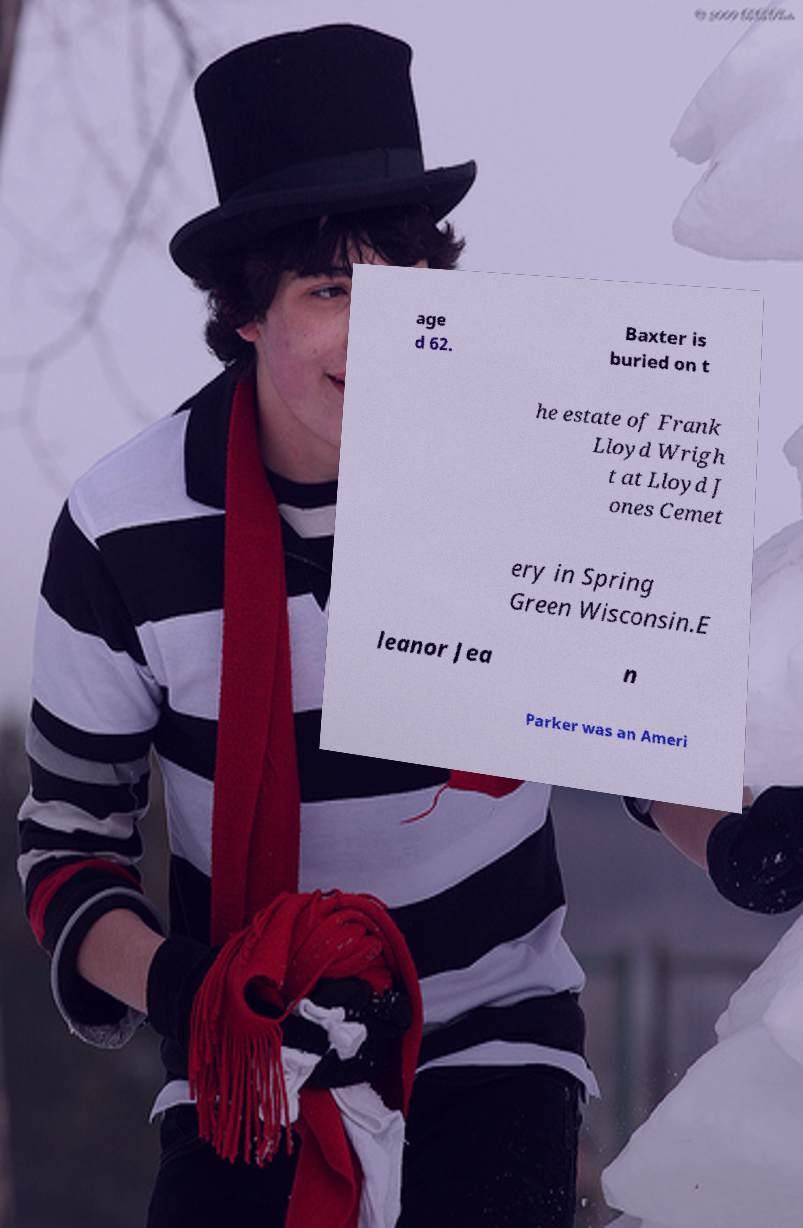Can you accurately transcribe the text from the provided image for me? age d 62. Baxter is buried on t he estate of Frank Lloyd Wrigh t at Lloyd J ones Cemet ery in Spring Green Wisconsin.E leanor Jea n Parker was an Ameri 